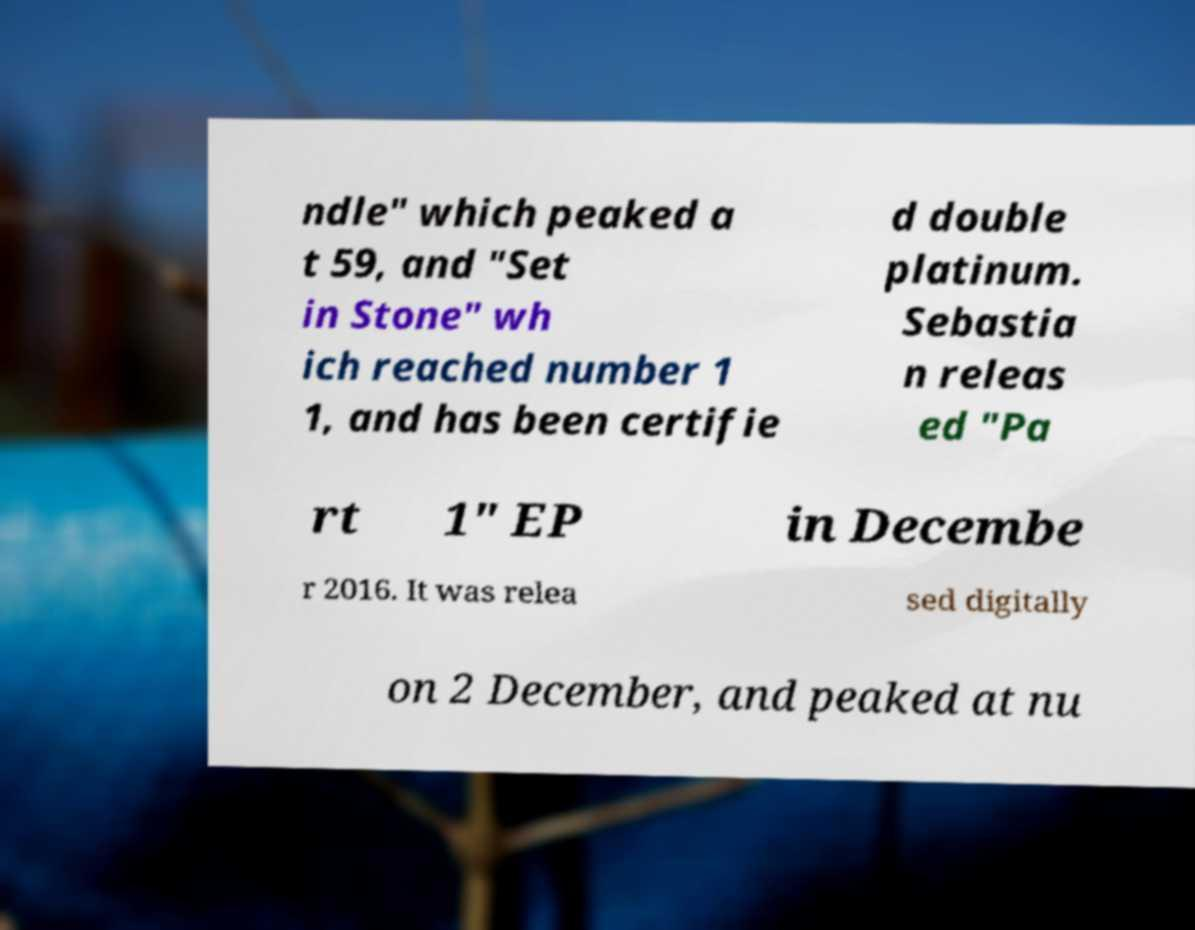Please identify and transcribe the text found in this image. ndle" which peaked a t 59, and "Set in Stone" wh ich reached number 1 1, and has been certifie d double platinum. Sebastia n releas ed "Pa rt 1" EP in Decembe r 2016. It was relea sed digitally on 2 December, and peaked at nu 